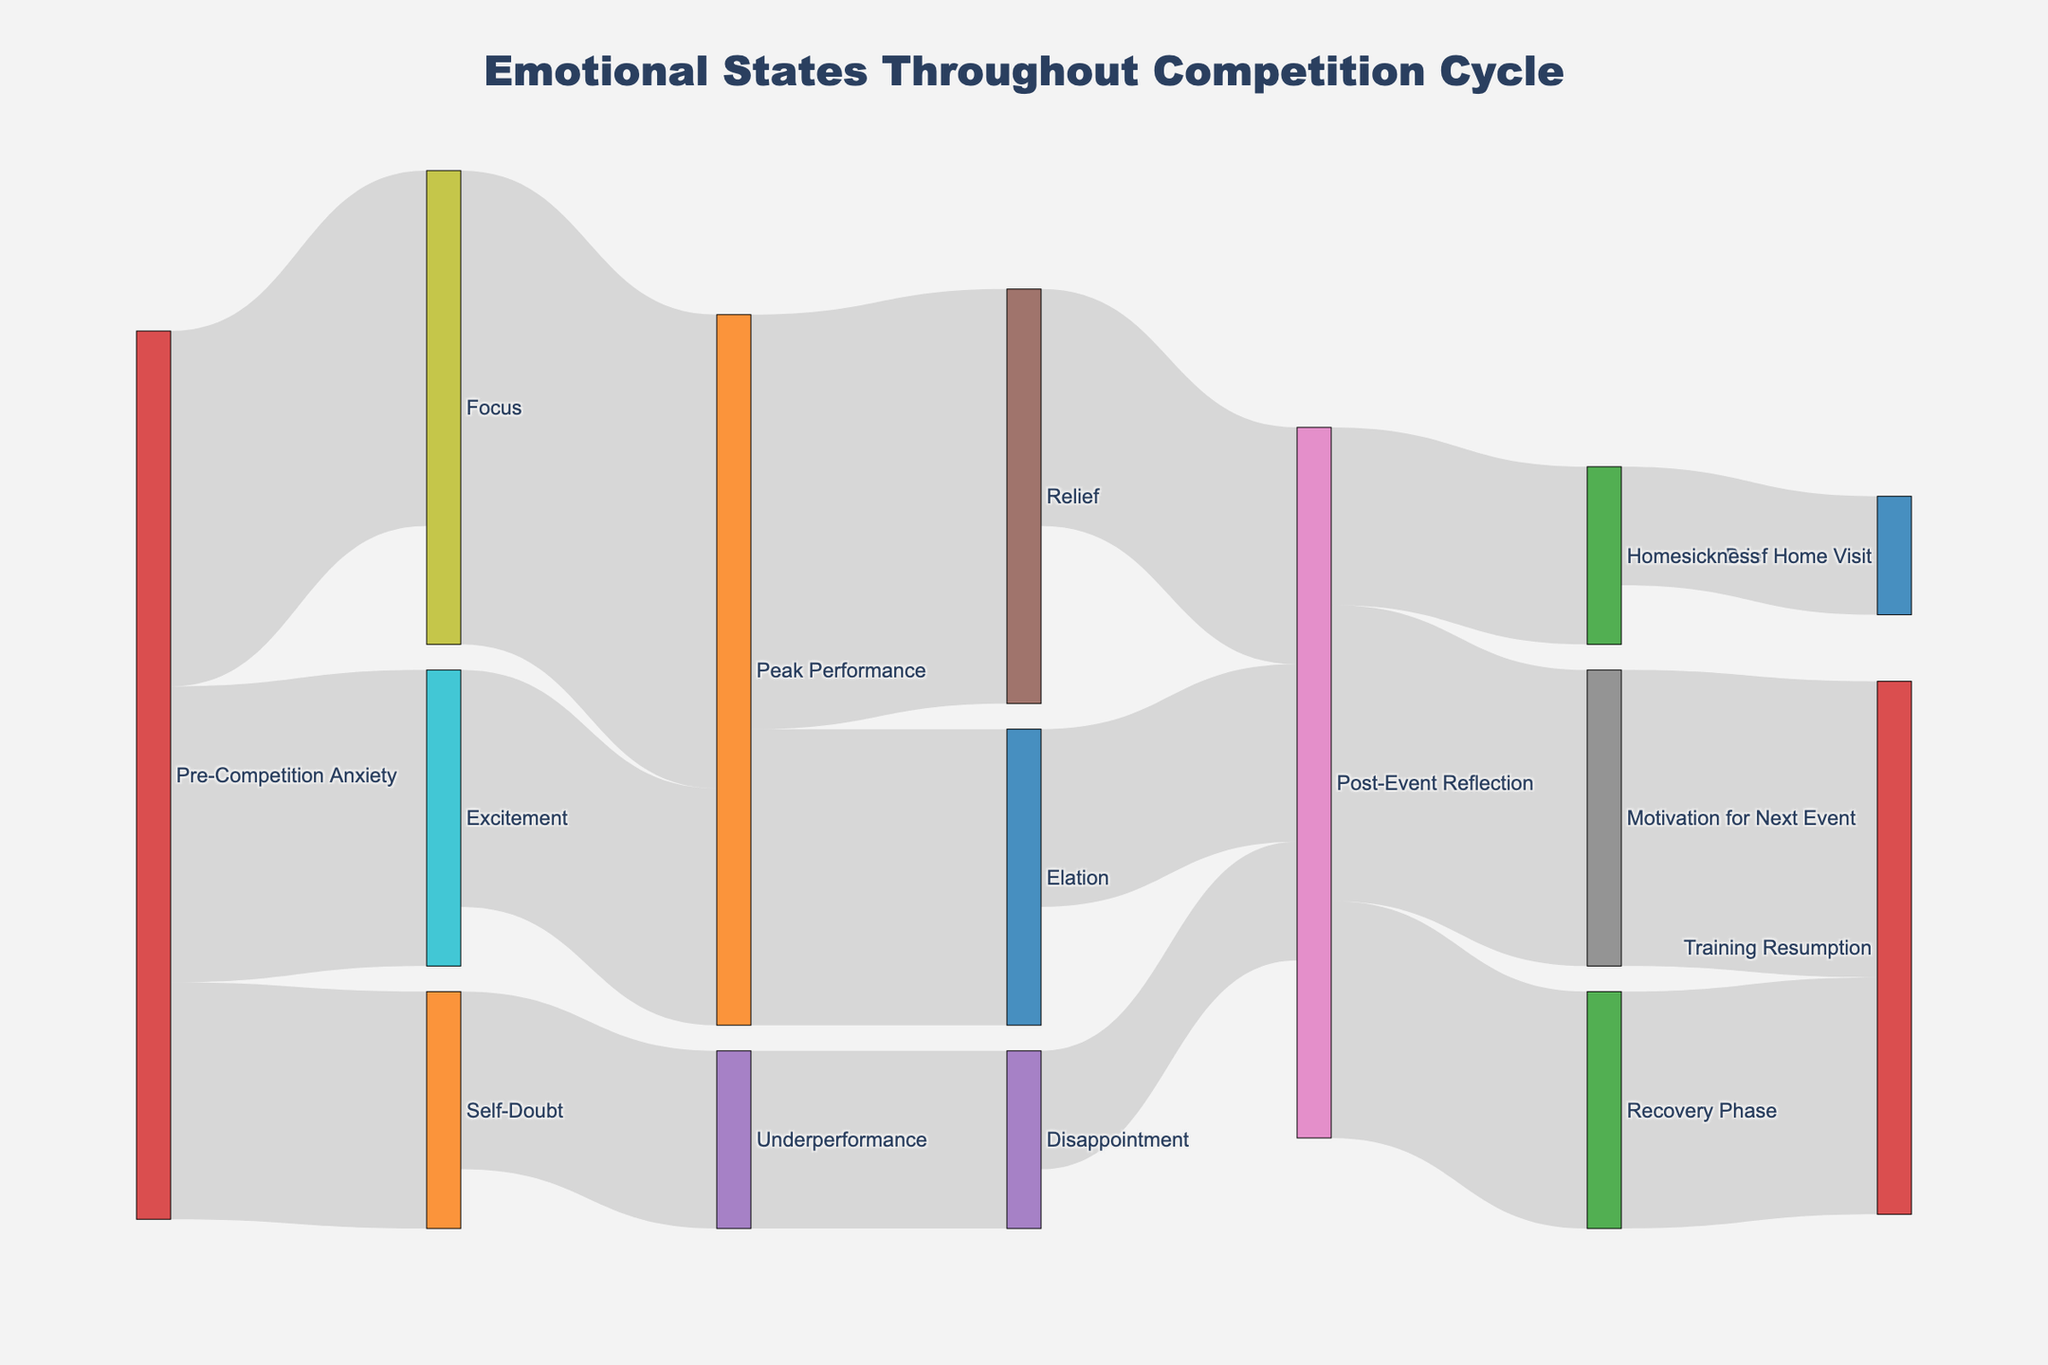What's the title of the Sankey diagram? The title is displayed prominently at the top of the diagram, indicating the overall subject it covers.
Answer: Emotional States Throughout Competition Cycle How many categories are shown going into 'Post-Event Reflection'? We need to count the number of links that lead to 'Post-Event Reflection'. These include links from Relief, Elation, and Disappointment.
Answer: 3 Which emotional state has the highest value from 'Pre-Competition Anxiety'? We look at the values linked to 'Focus', 'Self-Doubt', and 'Excitement' from 'Pre-Competition Anxiety' and identify the highest one, which is 30 for Focus.
Answer: Focus What is the total value that leads to 'Peak Performance'? We sum the values leading to 'Peak Performance' from 'Focus' and 'Excitement'. The values are 40 and 20, respectively, so the total is 60.
Answer: 60 Which emotional state leading into 'Underperformance' starts from 'Pre-Competition Anxiety'? Trace back from 'Underperformance' to see which emotional state directly links to it from 'Pre-Competition Anxiety'. It's 'Self-Doubt'.
Answer: Self-Doubt Compare the emotional states, which one has more significant value leading to 'Post-Event Reflection': 'Relief' or 'Disappointment'? Look at the values leading from 'Relief' (20) and 'Disappointment' (10) to 'Post-Event Reflection' and compare them.
Answer: Relief What two emotions transition into 'Training Resumption'? Identify the nodes that direct into 'Training Resumption'. These nodes are 'Motivation for Next Event' and 'Recovery Phase'.
Answer: Motivation for Next Event, Recovery Phase What percentage of 'Pre-Competition Anxiety' transitions into 'Self-Doubt'? Calculate the percentage as (value transitioning into 'Self-Doubt' / total value from 'Pre-Competition Anxiety') * 100. This is (20 / (30+20+25)) * 100 = 26.67%.
Answer: 26.67% Which emotional state has the highest sum of inbound values? Add up the values leading to each state and find the highest sum. 'Post-Event Reflection' has the highest sum with values 20 (Relief) + 15 (Elation) + 10 (Disappointment) = 45.
Answer: Post-Event Reflection What emotional states involve 'Homesickness' either as a source or a target? Look at both inbound and outbound links involving 'Homesickness'. It's sourced from 'Post-Event Reflection' and targets 'Brief Home Visit'.
Answer: Post-Event Reflection, Brief Home Visit 